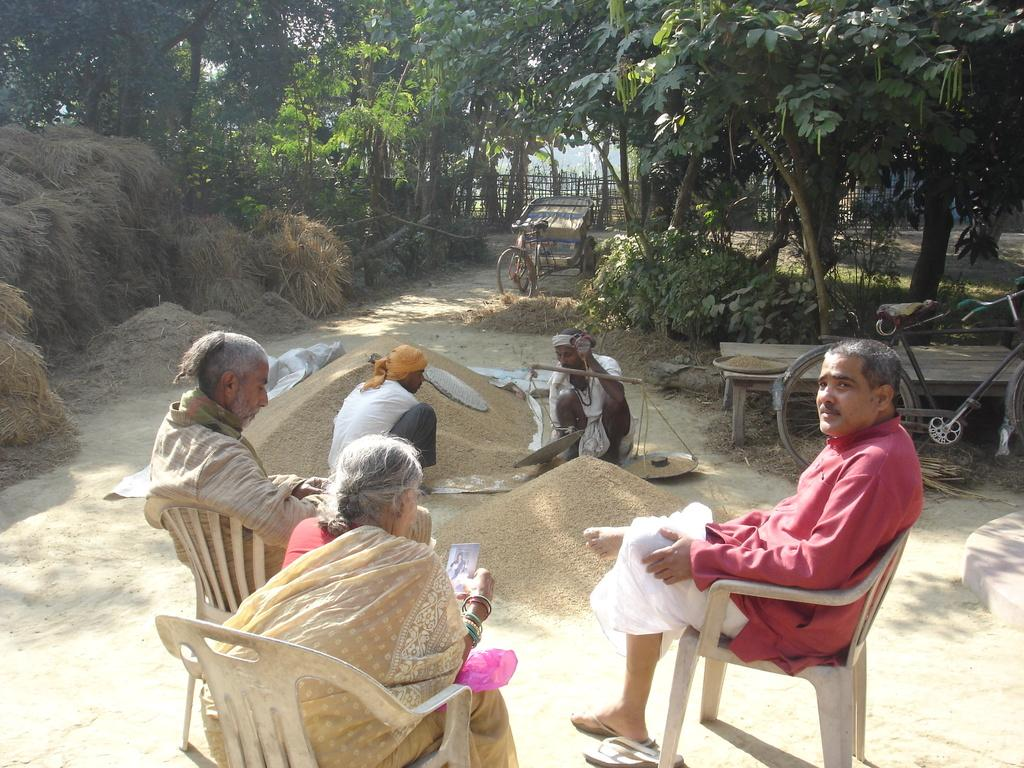How many people are in the image? There is a group of people in the image. What are the people doing in the image? The people are sitting on chairs. What is present on the ground in the image? There are trees on the ground in the image. What other objects can be seen in the image? There is a table and a bicycle in the image. Reasoning: Let'g: Let's think step by step in order to produce the conversation. We start by identifying the main subject in the image, which is the group of people. Then, we describe their actions, which is sitting on chairs. Next, we mention the presence of trees on the ground, as well as other objects like the table and bicycle. Each question is designed to elicit a specific detail about the image that is known from the provided facts. Absurd Question/Answer: What type of card is being used by the judge in the image? There is no judge or card present in the image. Can you tell me the color of the quartz on the table in the image? There is no quartz present in the image. 